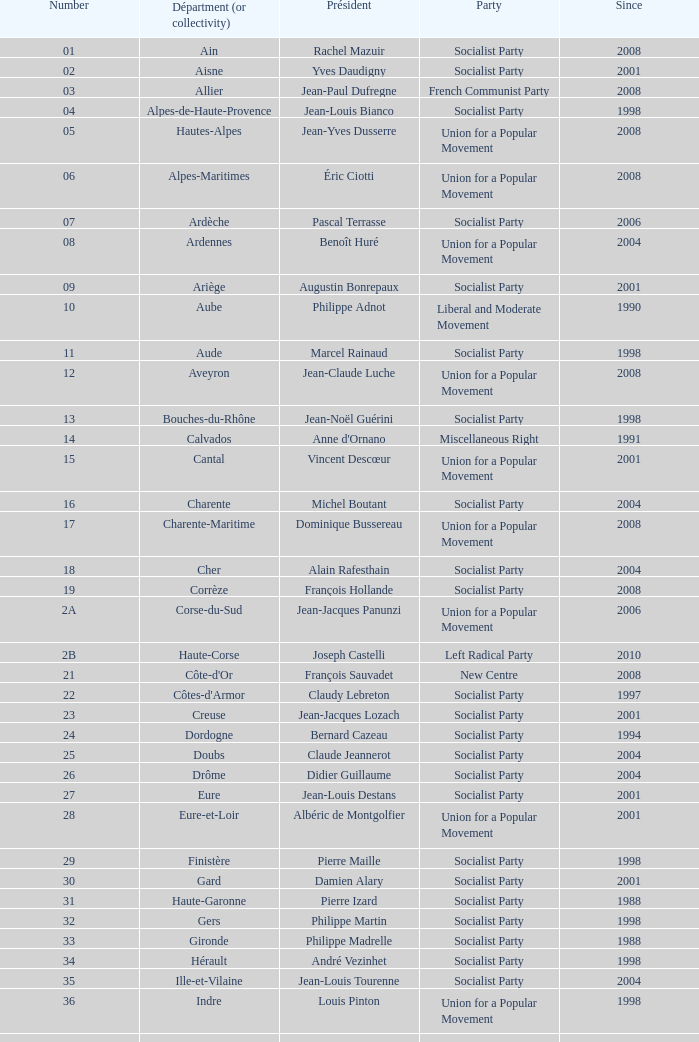In which unit has guy-dominique kennel held the position of president since 2008? Bas-Rhin. 